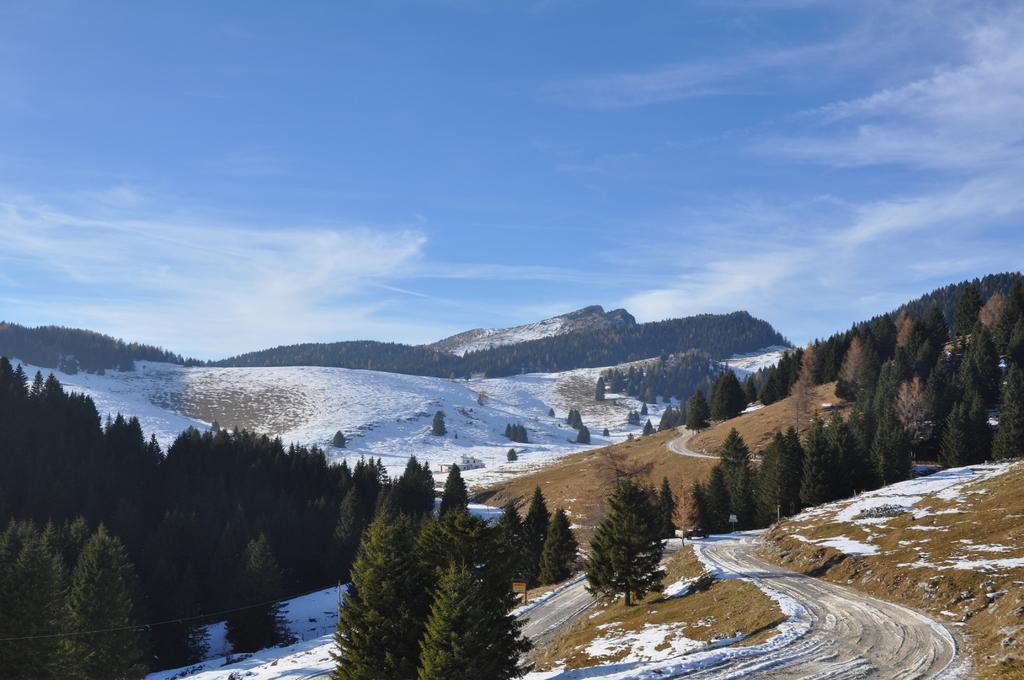Please provide a concise description of this image. In this picture I can see the ground and I see that it is covered with snow and I can see number of trees. In the background I can see the sky. 